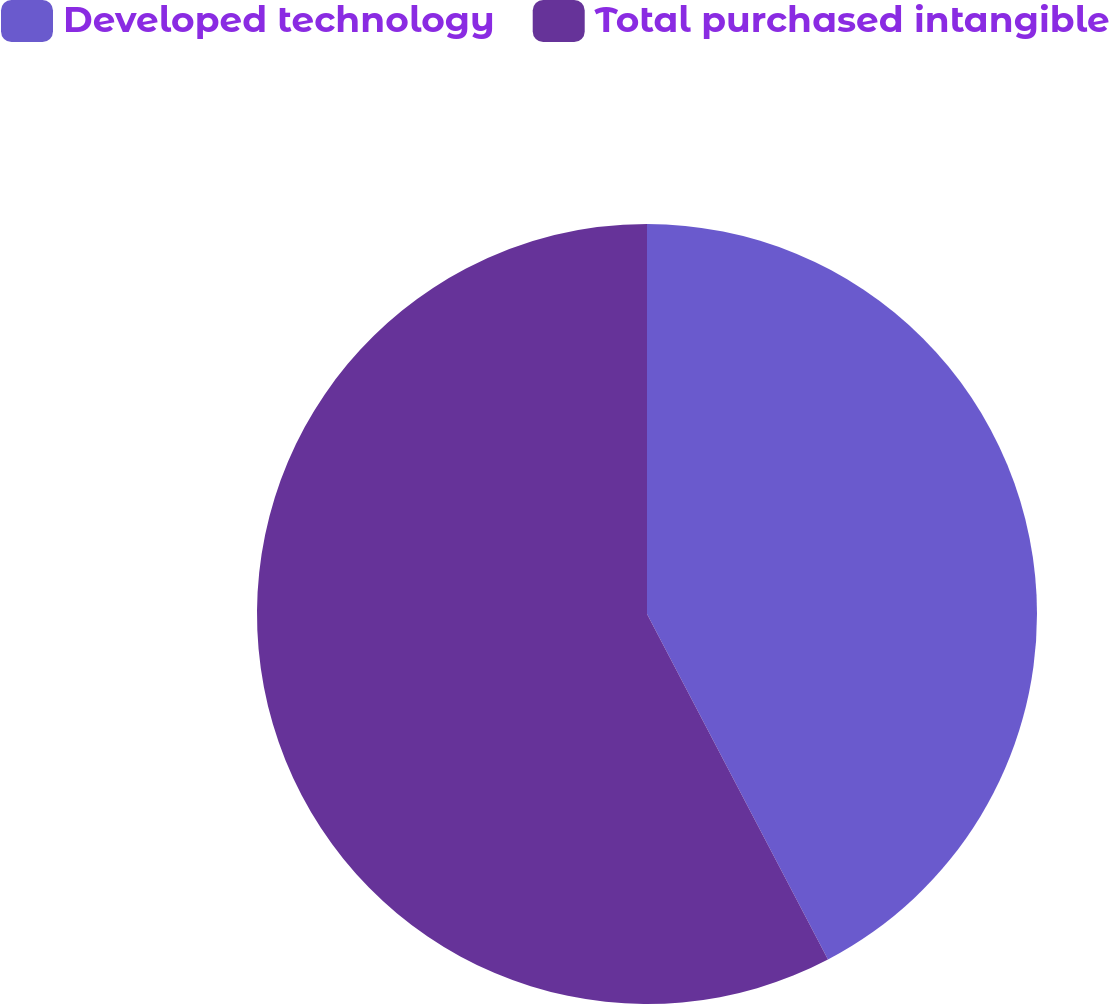Convert chart to OTSL. <chart><loc_0><loc_0><loc_500><loc_500><pie_chart><fcel>Developed technology<fcel>Total purchased intangible<nl><fcel>42.32%<fcel>57.68%<nl></chart> 